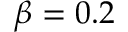Convert formula to latex. <formula><loc_0><loc_0><loc_500><loc_500>\beta = 0 . 2</formula> 